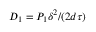<formula> <loc_0><loc_0><loc_500><loc_500>D _ { 1 } = P _ { 1 } \delta ^ { 2 } / ( 2 d \tau )</formula> 